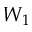<formula> <loc_0><loc_0><loc_500><loc_500>W _ { 1 }</formula> 